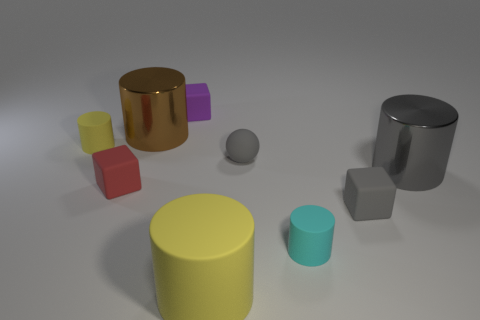Subtract all cyan cylinders. How many cylinders are left? 4 Subtract all brown cylinders. How many cylinders are left? 4 Subtract all red cylinders. Subtract all gray blocks. How many cylinders are left? 5 Add 1 purple matte things. How many objects exist? 10 Subtract all balls. How many objects are left? 8 Subtract all small red metallic blocks. Subtract all red things. How many objects are left? 8 Add 4 small yellow rubber things. How many small yellow rubber things are left? 5 Add 7 big cyan shiny balls. How many big cyan shiny balls exist? 7 Subtract 1 cyan cylinders. How many objects are left? 8 